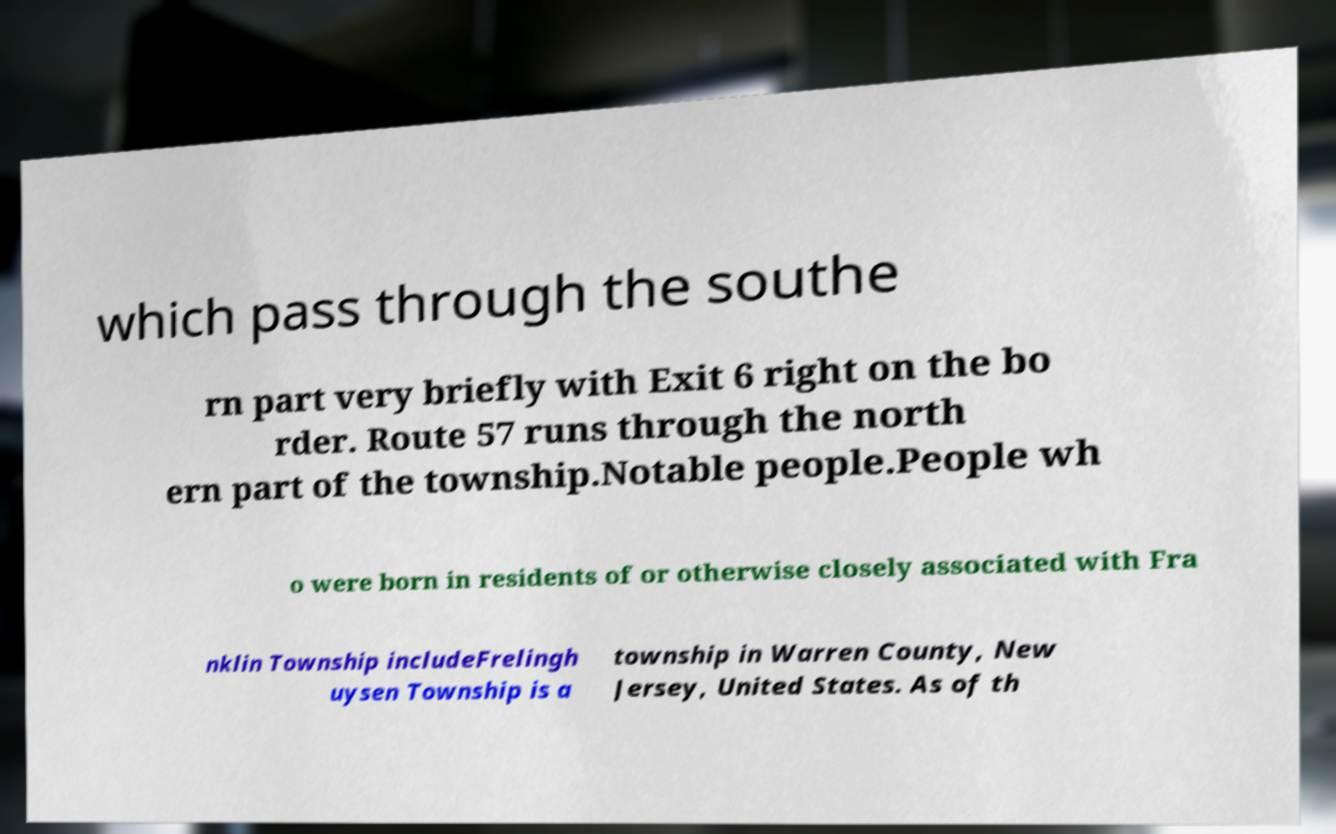Can you accurately transcribe the text from the provided image for me? which pass through the southe rn part very briefly with Exit 6 right on the bo rder. Route 57 runs through the north ern part of the township.Notable people.People wh o were born in residents of or otherwise closely associated with Fra nklin Township includeFrelingh uysen Township is a township in Warren County, New Jersey, United States. As of th 